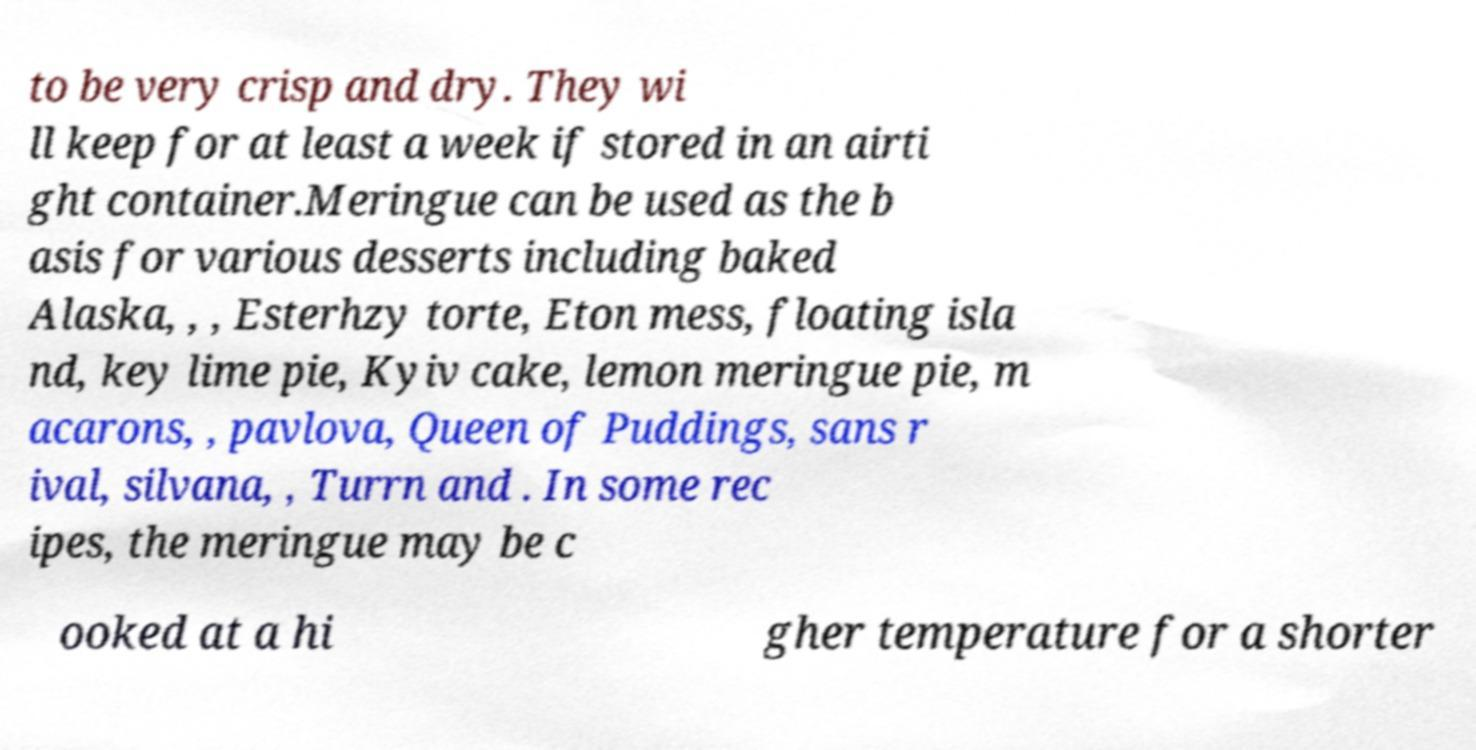What messages or text are displayed in this image? I need them in a readable, typed format. to be very crisp and dry. They wi ll keep for at least a week if stored in an airti ght container.Meringue can be used as the b asis for various desserts including baked Alaska, , , Esterhzy torte, Eton mess, floating isla nd, key lime pie, Kyiv cake, lemon meringue pie, m acarons, , pavlova, Queen of Puddings, sans r ival, silvana, , Turrn and . In some rec ipes, the meringue may be c ooked at a hi gher temperature for a shorter 